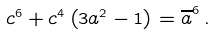<formula> <loc_0><loc_0><loc_500><loc_500>c ^ { 6 } + c ^ { 4 } \left ( 3 a ^ { 2 } - 1 \right ) = \overline { a } ^ { 6 } \, .</formula> 